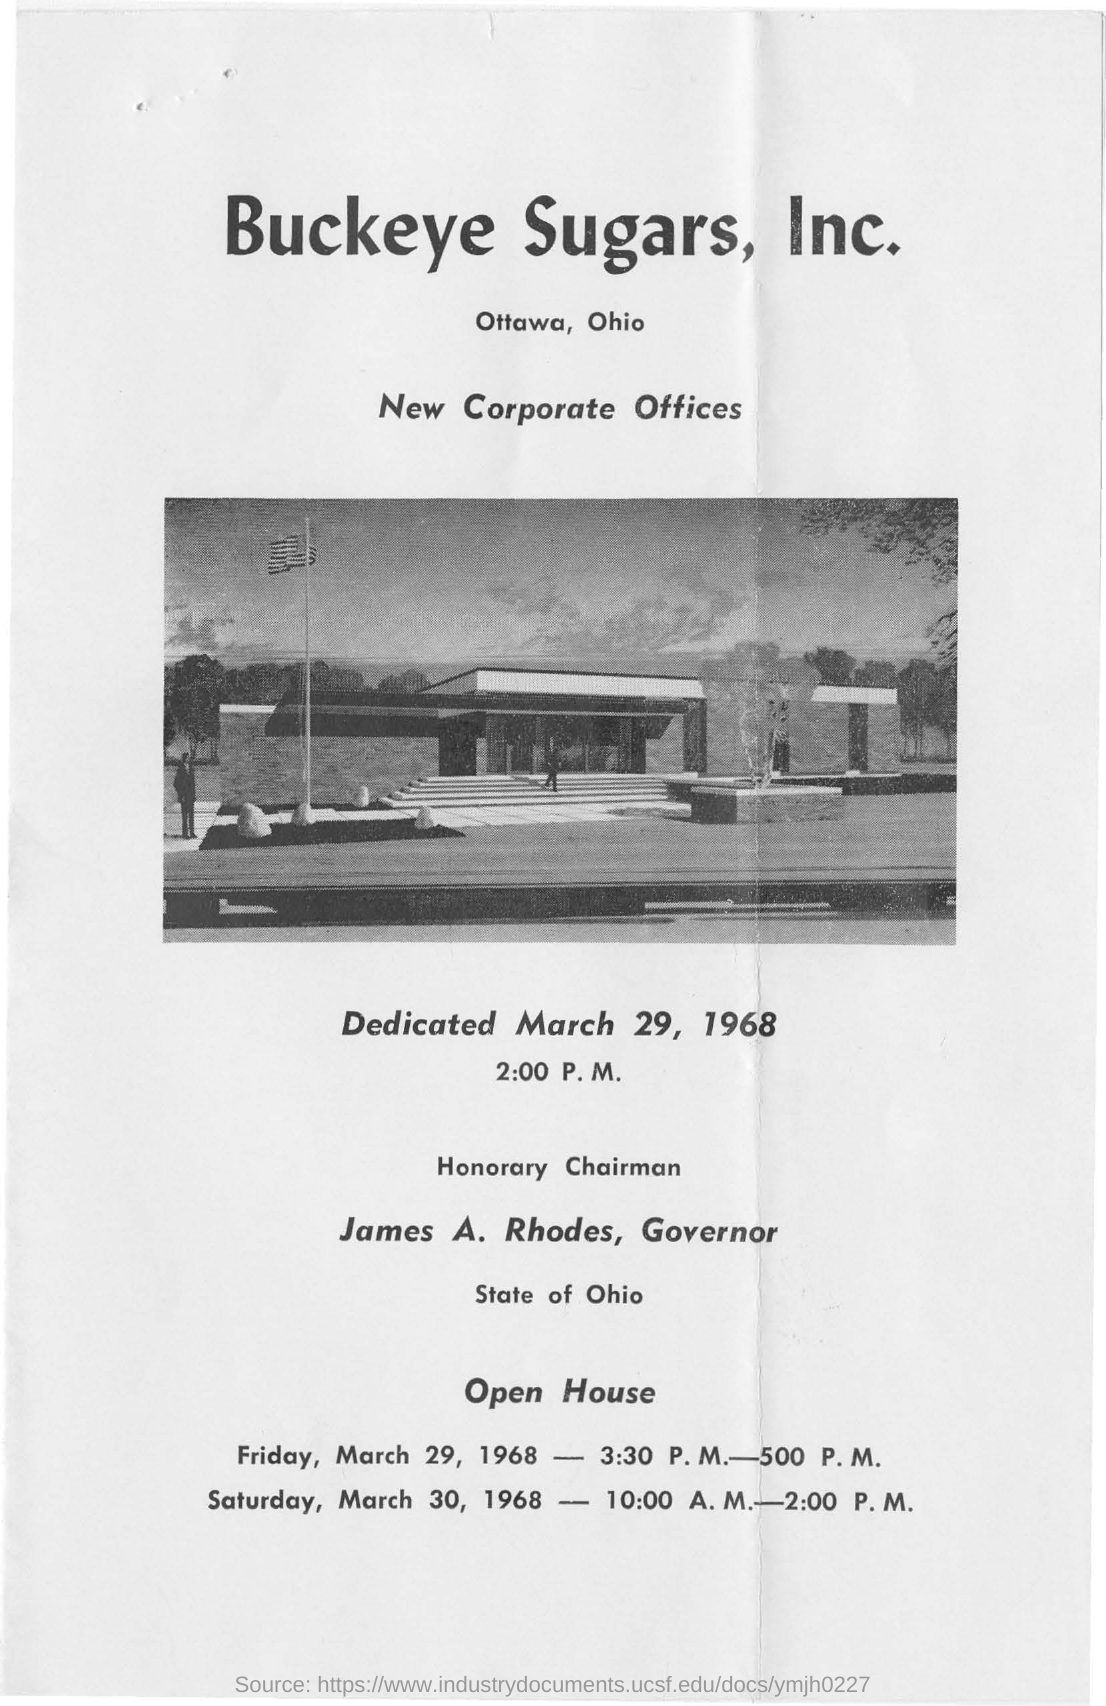Who is the Governor of State of Ohio?
Ensure brevity in your answer.  James A. Rhodes. Which company's new corporate offices are shown?
Offer a very short reply. BUCKEYE SUGARS, INC. 